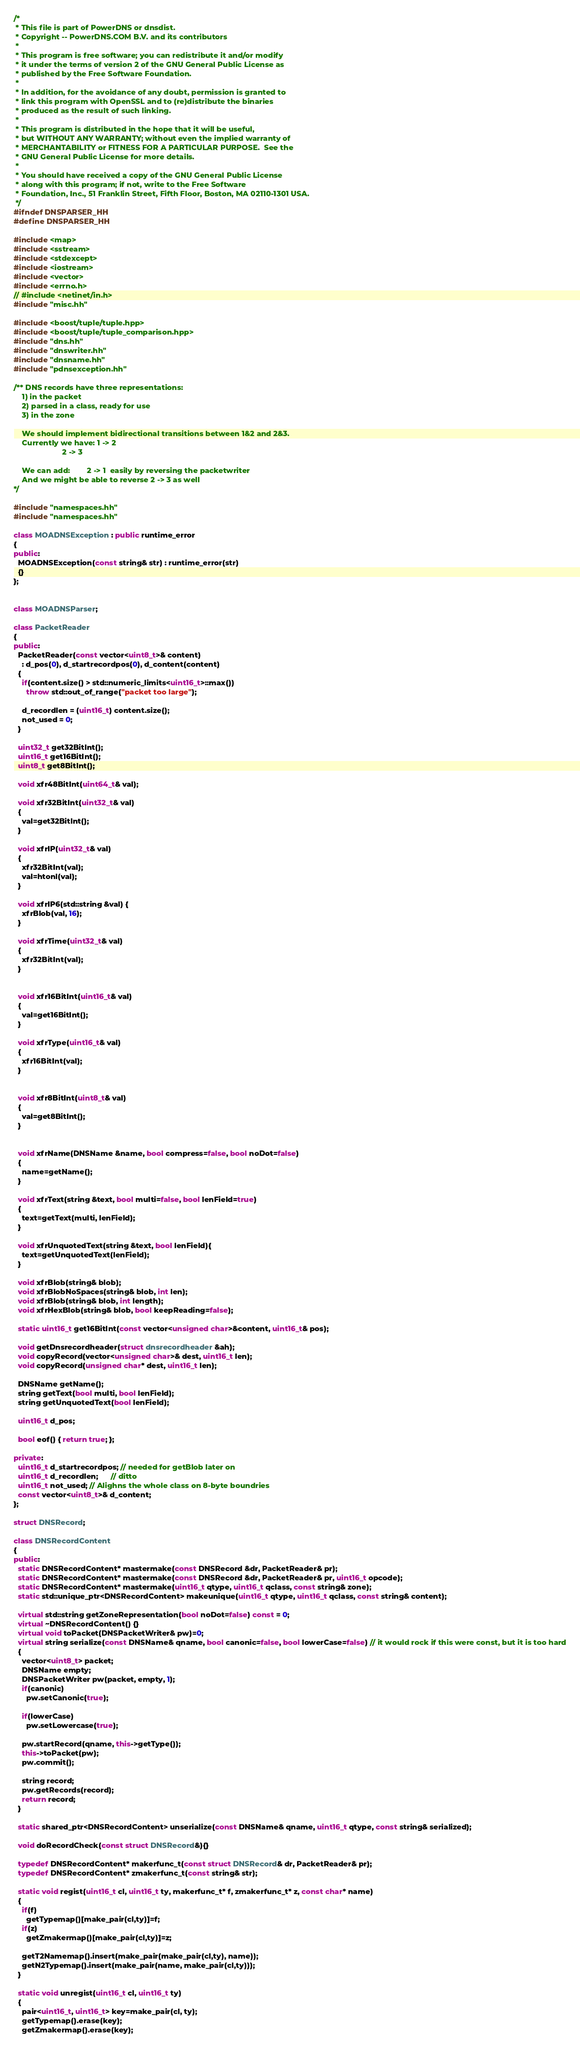Convert code to text. <code><loc_0><loc_0><loc_500><loc_500><_C++_>/*
 * This file is part of PowerDNS or dnsdist.
 * Copyright -- PowerDNS.COM B.V. and its contributors
 *
 * This program is free software; you can redistribute it and/or modify
 * it under the terms of version 2 of the GNU General Public License as
 * published by the Free Software Foundation.
 *
 * In addition, for the avoidance of any doubt, permission is granted to
 * link this program with OpenSSL and to (re)distribute the binaries
 * produced as the result of such linking.
 *
 * This program is distributed in the hope that it will be useful,
 * but WITHOUT ANY WARRANTY; without even the implied warranty of
 * MERCHANTABILITY or FITNESS FOR A PARTICULAR PURPOSE.  See the
 * GNU General Public License for more details.
 *
 * You should have received a copy of the GNU General Public License
 * along with this program; if not, write to the Free Software
 * Foundation, Inc., 51 Franklin Street, Fifth Floor, Boston, MA 02110-1301 USA.
 */
#ifndef DNSPARSER_HH
#define DNSPARSER_HH

#include <map>
#include <sstream>
#include <stdexcept>
#include <iostream>
#include <vector>
#include <errno.h>
// #include <netinet/in.h>
#include "misc.hh"

#include <boost/tuple/tuple.hpp>
#include <boost/tuple/tuple_comparison.hpp>
#include "dns.hh"
#include "dnswriter.hh"
#include "dnsname.hh"
#include "pdnsexception.hh"

/** DNS records have three representations:
    1) in the packet
    2) parsed in a class, ready for use
    3) in the zone

    We should implement bidirectional transitions between 1&2 and 2&3.
    Currently we have: 1 -> 2
                       2 -> 3

    We can add:        2 -> 1  easily by reversing the packetwriter
    And we might be able to reverse 2 -> 3 as well
*/
    
#include "namespaces.hh"
#include "namespaces.hh"

class MOADNSException : public runtime_error
{
public:
  MOADNSException(const string& str) : runtime_error(str)
  {}
};


class MOADNSParser;

class PacketReader
{
public:
  PacketReader(const vector<uint8_t>& content) 
    : d_pos(0), d_startrecordpos(0), d_content(content)
  {
    if(content.size() > std::numeric_limits<uint16_t>::max())
      throw std::out_of_range("packet too large");

    d_recordlen = (uint16_t) content.size();
    not_used = 0;
  }

  uint32_t get32BitInt();
  uint16_t get16BitInt();
  uint8_t get8BitInt();
  
  void xfr48BitInt(uint64_t& val);

  void xfr32BitInt(uint32_t& val)
  {
    val=get32BitInt();
  }

  void xfrIP(uint32_t& val)
  {
    xfr32BitInt(val);
    val=htonl(val);
  }

  void xfrIP6(std::string &val) {
    xfrBlob(val, 16);
  }

  void xfrTime(uint32_t& val)
  {
    xfr32BitInt(val);
  }


  void xfr16BitInt(uint16_t& val)
  {
    val=get16BitInt();
  }

  void xfrType(uint16_t& val)
  {
    xfr16BitInt(val);
  }


  void xfr8BitInt(uint8_t& val)
  {
    val=get8BitInt();
  }


  void xfrName(DNSName &name, bool compress=false, bool noDot=false)
  {
    name=getName();
  }

  void xfrText(string &text, bool multi=false, bool lenField=true)
  {
    text=getText(multi, lenField);
  }

  void xfrUnquotedText(string &text, bool lenField){
    text=getUnquotedText(lenField);
  }

  void xfrBlob(string& blob);
  void xfrBlobNoSpaces(string& blob, int len);
  void xfrBlob(string& blob, int length);
  void xfrHexBlob(string& blob, bool keepReading=false);

  static uint16_t get16BitInt(const vector<unsigned char>&content, uint16_t& pos);

  void getDnsrecordheader(struct dnsrecordheader &ah);
  void copyRecord(vector<unsigned char>& dest, uint16_t len);
  void copyRecord(unsigned char* dest, uint16_t len);

  DNSName getName();
  string getText(bool multi, bool lenField);
  string getUnquotedText(bool lenField);

  uint16_t d_pos;

  bool eof() { return true; };

private:
  uint16_t d_startrecordpos; // needed for getBlob later on
  uint16_t d_recordlen;      // ditto
  uint16_t not_used; // Alighns the whole class on 8-byte boundries
  const vector<uint8_t>& d_content;
};

struct DNSRecord;

class DNSRecordContent
{
public:
  static DNSRecordContent* mastermake(const DNSRecord &dr, PacketReader& pr);
  static DNSRecordContent* mastermake(const DNSRecord &dr, PacketReader& pr, uint16_t opcode);
  static DNSRecordContent* mastermake(uint16_t qtype, uint16_t qclass, const string& zone);
  static std::unique_ptr<DNSRecordContent> makeunique(uint16_t qtype, uint16_t qclass, const string& content);

  virtual std::string getZoneRepresentation(bool noDot=false) const = 0;
  virtual ~DNSRecordContent() {}
  virtual void toPacket(DNSPacketWriter& pw)=0;
  virtual string serialize(const DNSName& qname, bool canonic=false, bool lowerCase=false) // it would rock if this were const, but it is too hard
  {
    vector<uint8_t> packet;
    DNSName empty;
    DNSPacketWriter pw(packet, empty, 1);
    if(canonic)
      pw.setCanonic(true);

    if(lowerCase)
      pw.setLowercase(true);

    pw.startRecord(qname, this->getType());
    this->toPacket(pw);
    pw.commit();
    
    string record;
    pw.getRecords(record);
    return record;
  }

  static shared_ptr<DNSRecordContent> unserialize(const DNSName& qname, uint16_t qtype, const string& serialized);

  void doRecordCheck(const struct DNSRecord&){}

  typedef DNSRecordContent* makerfunc_t(const struct DNSRecord& dr, PacketReader& pr);  
  typedef DNSRecordContent* zmakerfunc_t(const string& str);  

  static void regist(uint16_t cl, uint16_t ty, makerfunc_t* f, zmakerfunc_t* z, const char* name)
  {
    if(f)
      getTypemap()[make_pair(cl,ty)]=f;
    if(z)
      getZmakermap()[make_pair(cl,ty)]=z;

    getT2Namemap().insert(make_pair(make_pair(cl,ty), name));
    getN2Typemap().insert(make_pair(name, make_pair(cl,ty)));
  }

  static void unregist(uint16_t cl, uint16_t ty) 
  {
    pair<uint16_t, uint16_t> key=make_pair(cl, ty);
    getTypemap().erase(key);
    getZmakermap().erase(key);</code> 